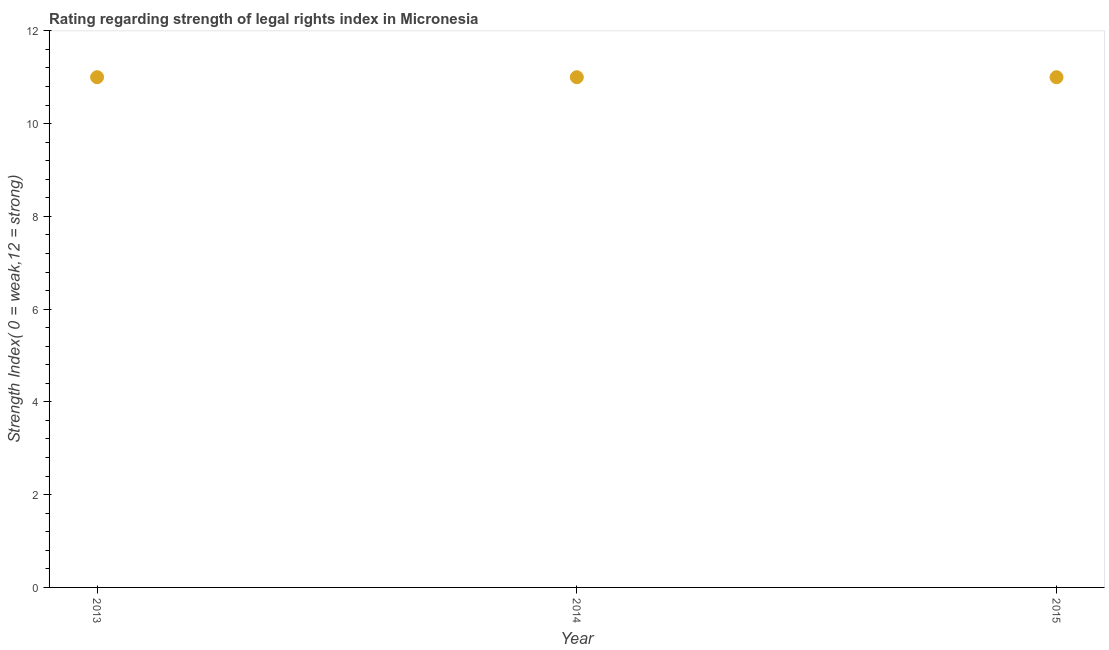What is the strength of legal rights index in 2014?
Your answer should be very brief. 11. Across all years, what is the maximum strength of legal rights index?
Your answer should be very brief. 11. Across all years, what is the minimum strength of legal rights index?
Offer a very short reply. 11. In which year was the strength of legal rights index maximum?
Your response must be concise. 2013. What is the sum of the strength of legal rights index?
Your answer should be very brief. 33. What is the difference between the strength of legal rights index in 2014 and 2015?
Provide a succinct answer. 0. What is the average strength of legal rights index per year?
Make the answer very short. 11. Do a majority of the years between 2015 and 2013 (inclusive) have strength of legal rights index greater than 10 ?
Ensure brevity in your answer.  No. What is the ratio of the strength of legal rights index in 2013 to that in 2014?
Make the answer very short. 1. Is the sum of the strength of legal rights index in 2013 and 2014 greater than the maximum strength of legal rights index across all years?
Your answer should be compact. Yes. In how many years, is the strength of legal rights index greater than the average strength of legal rights index taken over all years?
Keep it short and to the point. 0. Does the strength of legal rights index monotonically increase over the years?
Give a very brief answer. No. How many dotlines are there?
Give a very brief answer. 1. Are the values on the major ticks of Y-axis written in scientific E-notation?
Your answer should be very brief. No. Does the graph contain any zero values?
Provide a succinct answer. No. Does the graph contain grids?
Make the answer very short. No. What is the title of the graph?
Make the answer very short. Rating regarding strength of legal rights index in Micronesia. What is the label or title of the X-axis?
Ensure brevity in your answer.  Year. What is the label or title of the Y-axis?
Your response must be concise. Strength Index( 0 = weak,12 = strong). What is the Strength Index( 0 = weak,12 = strong) in 2013?
Provide a short and direct response. 11. What is the Strength Index( 0 = weak,12 = strong) in 2015?
Offer a very short reply. 11. What is the difference between the Strength Index( 0 = weak,12 = strong) in 2014 and 2015?
Your answer should be compact. 0. What is the ratio of the Strength Index( 0 = weak,12 = strong) in 2013 to that in 2014?
Your response must be concise. 1. What is the ratio of the Strength Index( 0 = weak,12 = strong) in 2013 to that in 2015?
Offer a terse response. 1. What is the ratio of the Strength Index( 0 = weak,12 = strong) in 2014 to that in 2015?
Your response must be concise. 1. 